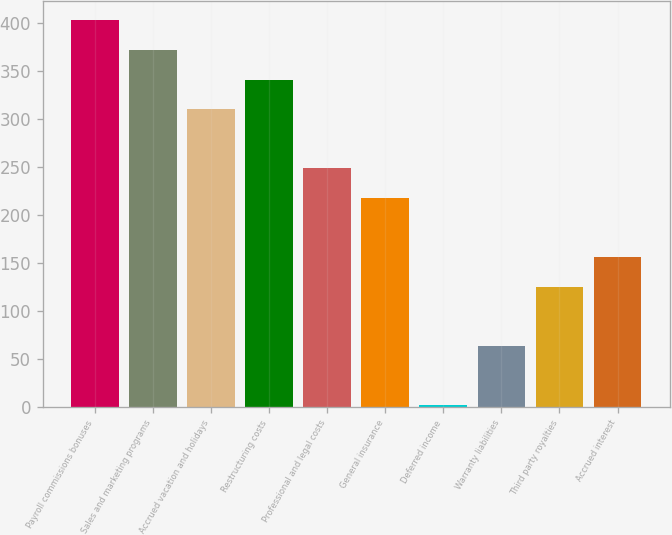<chart> <loc_0><loc_0><loc_500><loc_500><bar_chart><fcel>Payroll commissions bonuses<fcel>Sales and marketing programs<fcel>Accrued vacation and holidays<fcel>Restructuring costs<fcel>Professional and legal costs<fcel>General insurance<fcel>Deferred income<fcel>Warranty liabilities<fcel>Third party royalties<fcel>Accrued interest<nl><fcel>402.47<fcel>371.68<fcel>310.1<fcel>340.89<fcel>248.52<fcel>217.73<fcel>2.2<fcel>63.78<fcel>125.36<fcel>156.15<nl></chart> 